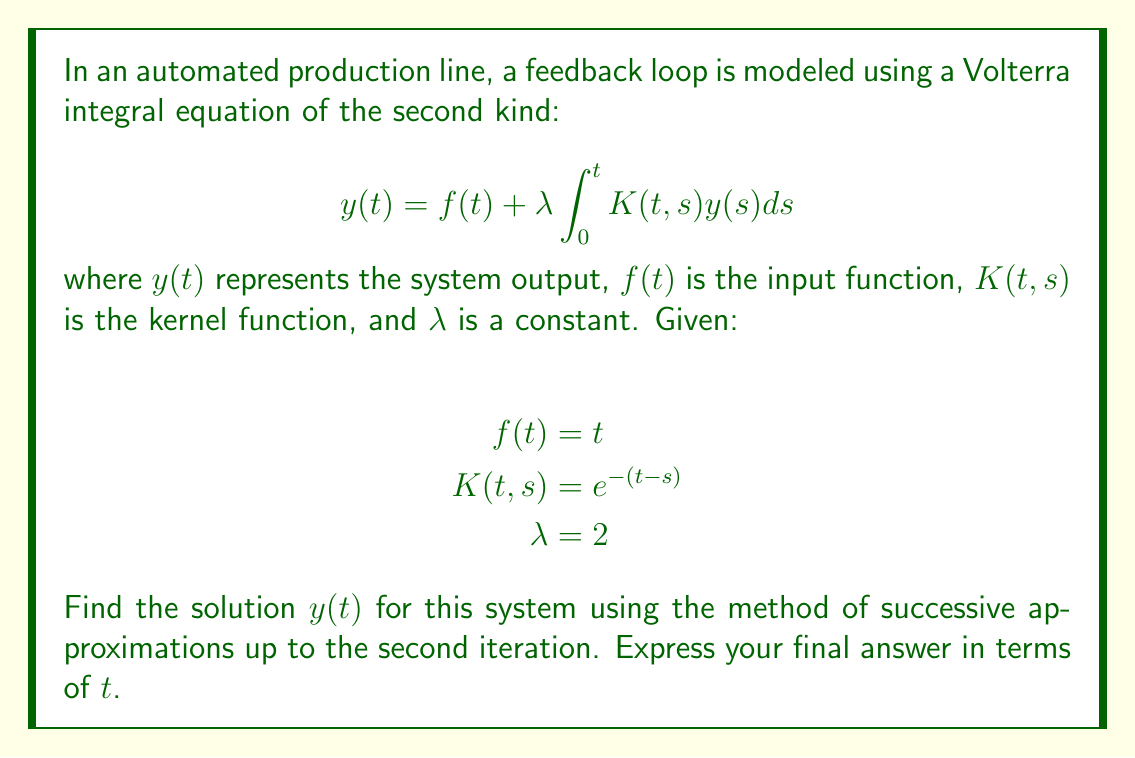Give your solution to this math problem. To solve this Volterra integral equation using the method of successive approximations, we'll follow these steps:

1) Start with the initial approximation $y_0(t) = f(t)$:
   $y_0(t) = t$

2) Use the recurrence relation:
   $y_{n+1}(t) = f(t) + \lambda \int_0^t K(t,s)y_n(s)ds$

3) Calculate $y_1(t)$:
   $$\begin{align*}
   y_1(t) &= t + 2 \int_0^t e^{-(t-s)}s ds \\
   &= t + 2 \left[ -se^{-(t-s)} - e^{-(t-s)} \right]_0^t \\
   &= t + 2 \left[ -te^0 - e^0 + 0 + e^{-t} \right] \\
   &= t - 2t - 2 + 2e^{-t} \\
   &= -t - 2 + 2e^{-t}
   \end{align*}$$

4) Calculate $y_2(t)$:
   $$\begin{align*}
   y_2(t) &= t + 2 \int_0^t e^{-(t-s)}(-s - 2 + 2e^{-s}) ds \\
   &= t + 2 \left[ -se^{-(t-s)} - e^{-(t-s)} - 2e^{-(t-s)} + 2e^{-t}e^s \right]_0^t \\
   &= t + 2 \left[ -te^0 - e^0 - 2e^0 + 2e^{-t}e^t - 0 - e^{-t} - 2e^{-t} + 2e^{-t}e^0 \right] \\
   &= t - 2t - 2 - 4 + 4 - 2e^{-t} - 4e^{-t} + 4e^{-t} \\
   &= -t - 6 - 2e^{-t}
   \end{align*}$$

Therefore, the second iteration approximation for $y(t)$ is $-t - 6 - 2e^{-t}$.
Answer: $y(t) \approx -t - 6 - 2e^{-t}$ 